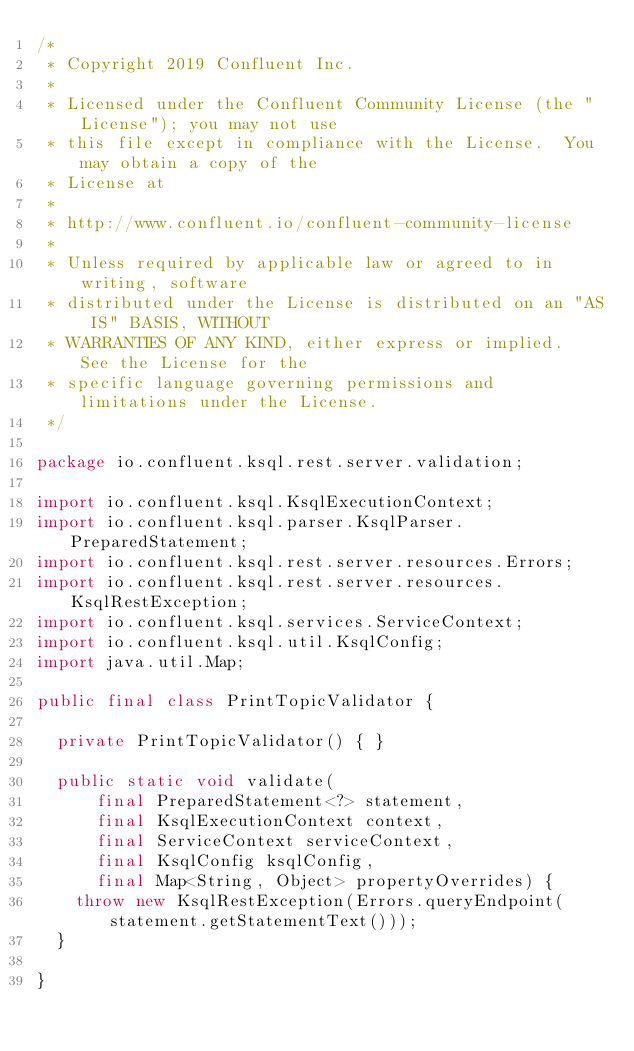<code> <loc_0><loc_0><loc_500><loc_500><_Java_>/*
 * Copyright 2019 Confluent Inc.
 *
 * Licensed under the Confluent Community License (the "License"); you may not use
 * this file except in compliance with the License.  You may obtain a copy of the
 * License at
 *
 * http://www.confluent.io/confluent-community-license
 *
 * Unless required by applicable law or agreed to in writing, software
 * distributed under the License is distributed on an "AS IS" BASIS, WITHOUT
 * WARRANTIES OF ANY KIND, either express or implied.  See the License for the
 * specific language governing permissions and limitations under the License.
 */

package io.confluent.ksql.rest.server.validation;

import io.confluent.ksql.KsqlExecutionContext;
import io.confluent.ksql.parser.KsqlParser.PreparedStatement;
import io.confluent.ksql.rest.server.resources.Errors;
import io.confluent.ksql.rest.server.resources.KsqlRestException;
import io.confluent.ksql.services.ServiceContext;
import io.confluent.ksql.util.KsqlConfig;
import java.util.Map;

public final class PrintTopicValidator {

  private PrintTopicValidator() { }

  public static void validate(
      final PreparedStatement<?> statement,
      final KsqlExecutionContext context,
      final ServiceContext serviceContext,
      final KsqlConfig ksqlConfig,
      final Map<String, Object> propertyOverrides) {
    throw new KsqlRestException(Errors.queryEndpoint(statement.getStatementText()));
  }

}
</code> 